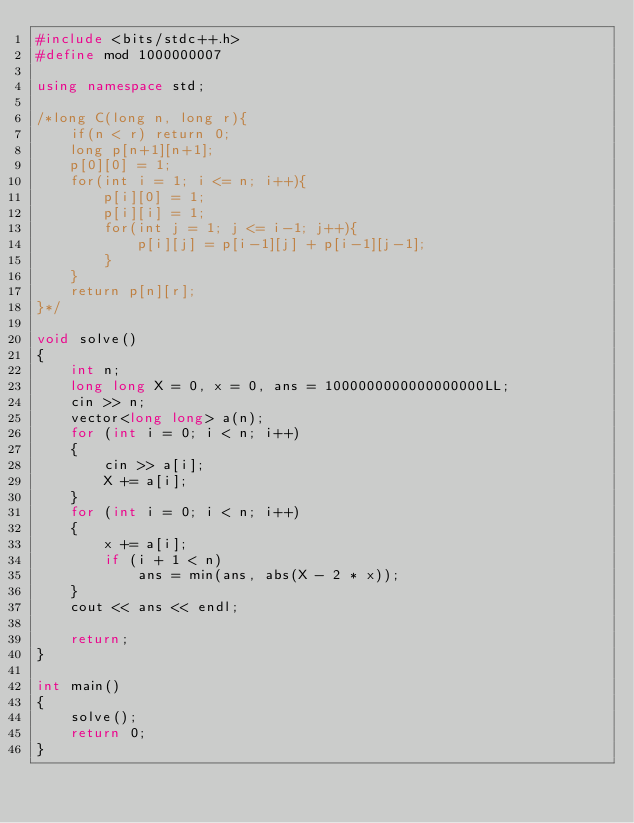Convert code to text. <code><loc_0><loc_0><loc_500><loc_500><_C++_>#include <bits/stdc++.h>
#define mod 1000000007

using namespace std;

/*long C(long n, long r){
    if(n < r) return 0;
    long p[n+1][n+1];
    p[0][0] = 1;
    for(int i = 1; i <= n; i++){
        p[i][0] = 1;
        p[i][i] = 1;
        for(int j = 1; j <= i-1; j++){
            p[i][j] = p[i-1][j] + p[i-1][j-1];
        }
    }
    return p[n][r];
}*/

void solve()
{
    int n;
    long long X = 0, x = 0, ans = 1000000000000000000LL;
    cin >> n;
    vector<long long> a(n);
    for (int i = 0; i < n; i++)
    {
        cin >> a[i];
        X += a[i];
    }
    for (int i = 0; i < n; i++)
    {
        x += a[i];
        if (i + 1 < n)
            ans = min(ans, abs(X - 2 * x));
    }
    cout << ans << endl;

    return;
}

int main()
{
    solve();
    return 0;
}</code> 